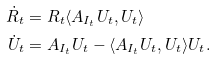Convert formula to latex. <formula><loc_0><loc_0><loc_500><loc_500>\dot { R } _ { t } & = R _ { t } \langle A _ { I _ { t } } U _ { t } , U _ { t } \rangle \\ \dot { U } _ { t } & = A _ { I _ { t } } U _ { t } - \langle A _ { I _ { t } } U _ { t } , U _ { t } \rangle U _ { t } .</formula> 